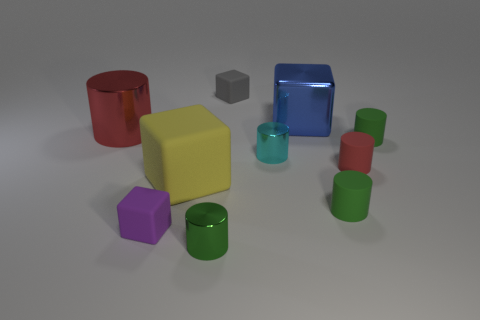Are there fewer gray blocks in front of the gray thing than brown balls?
Give a very brief answer. No. What number of other things are there of the same shape as the yellow thing?
Provide a short and direct response. 3. Is there any other thing that has the same color as the large metallic cylinder?
Ensure brevity in your answer.  Yes. Is the color of the big metal cylinder the same as the tiny matte block behind the large red metallic thing?
Provide a succinct answer. No. How many other things are there of the same size as the cyan cylinder?
Give a very brief answer. 6. How many cylinders are red metallic objects or cyan metal objects?
Make the answer very short. 2. There is a small rubber object that is on the right side of the small red cylinder; does it have the same shape as the big red thing?
Provide a short and direct response. Yes. Are there more small cyan objects that are behind the small green metal thing than big cyan metal blocks?
Keep it short and to the point. Yes. What is the color of the other cube that is the same size as the gray rubber block?
Keep it short and to the point. Purple. What number of objects are either objects that are right of the red metal cylinder or gray balls?
Offer a terse response. 9. 